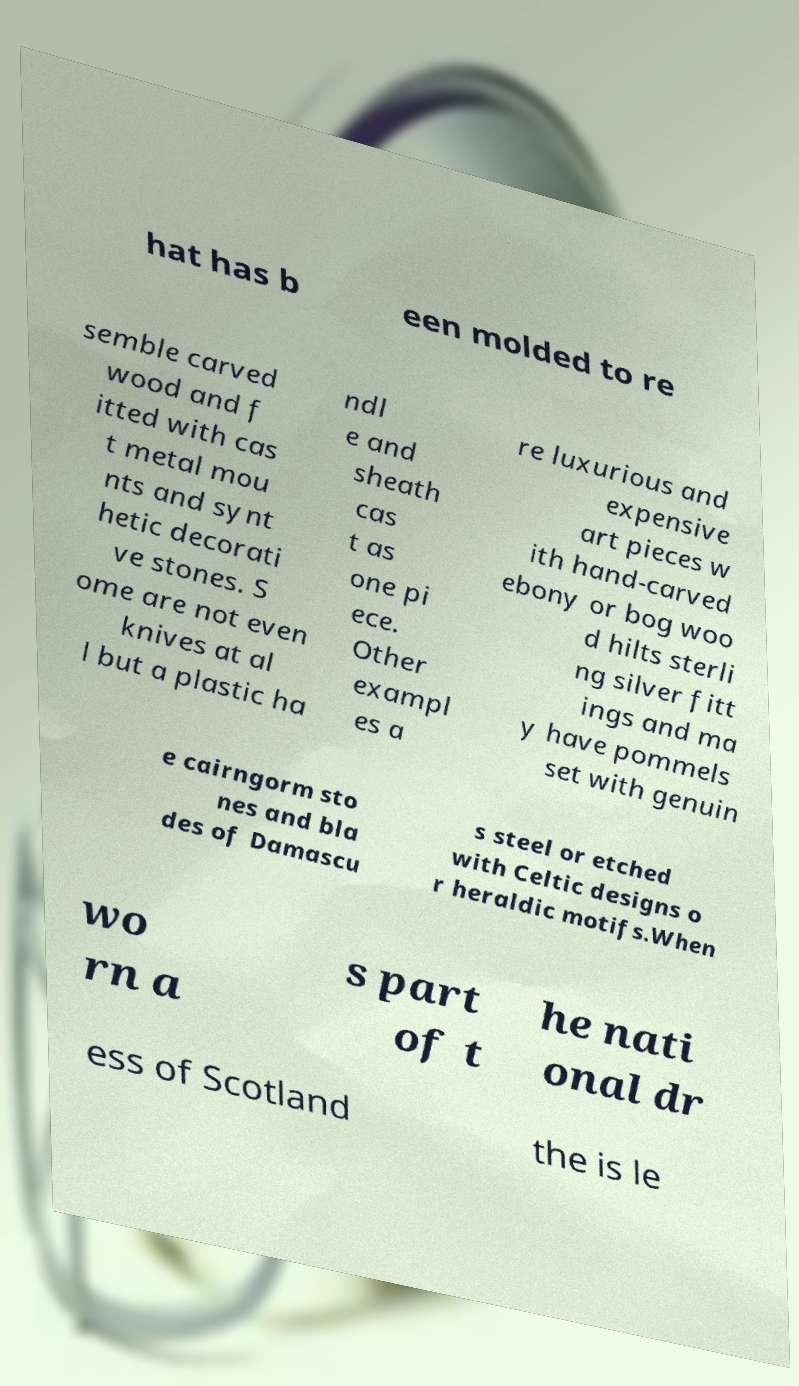Could you assist in decoding the text presented in this image and type it out clearly? hat has b een molded to re semble carved wood and f itted with cas t metal mou nts and synt hetic decorati ve stones. S ome are not even knives at al l but a plastic ha ndl e and sheath cas t as one pi ece. Other exampl es a re luxurious and expensive art pieces w ith hand-carved ebony or bog woo d hilts sterli ng silver fitt ings and ma y have pommels set with genuin e cairngorm sto nes and bla des of Damascu s steel or etched with Celtic designs o r heraldic motifs.When wo rn a s part of t he nati onal dr ess of Scotland the is le 